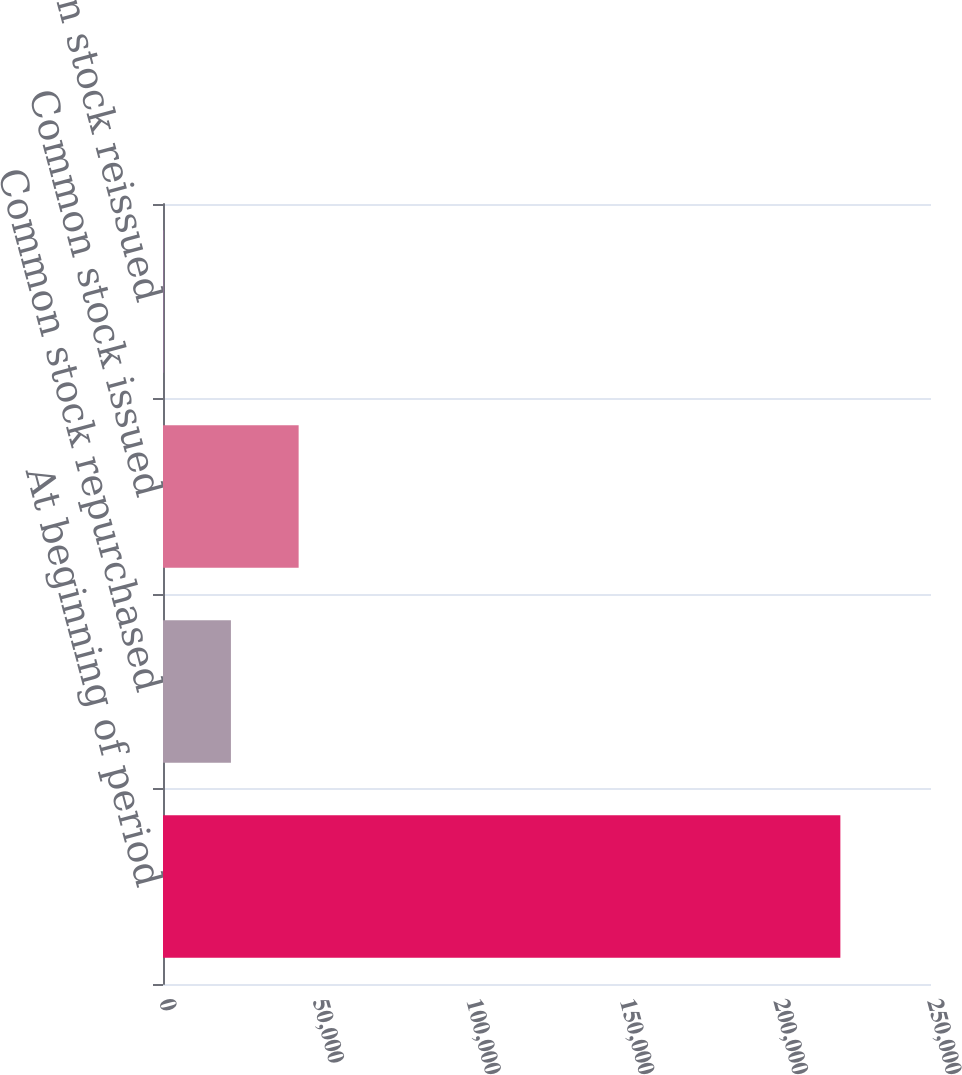Convert chart to OTSL. <chart><loc_0><loc_0><loc_500><loc_500><bar_chart><fcel>At beginning of period<fcel>Common stock repurchased<fcel>Common stock issued<fcel>Common stock reissued<nl><fcel>220497<fcel>22110.9<fcel>44153.8<fcel>68<nl></chart> 